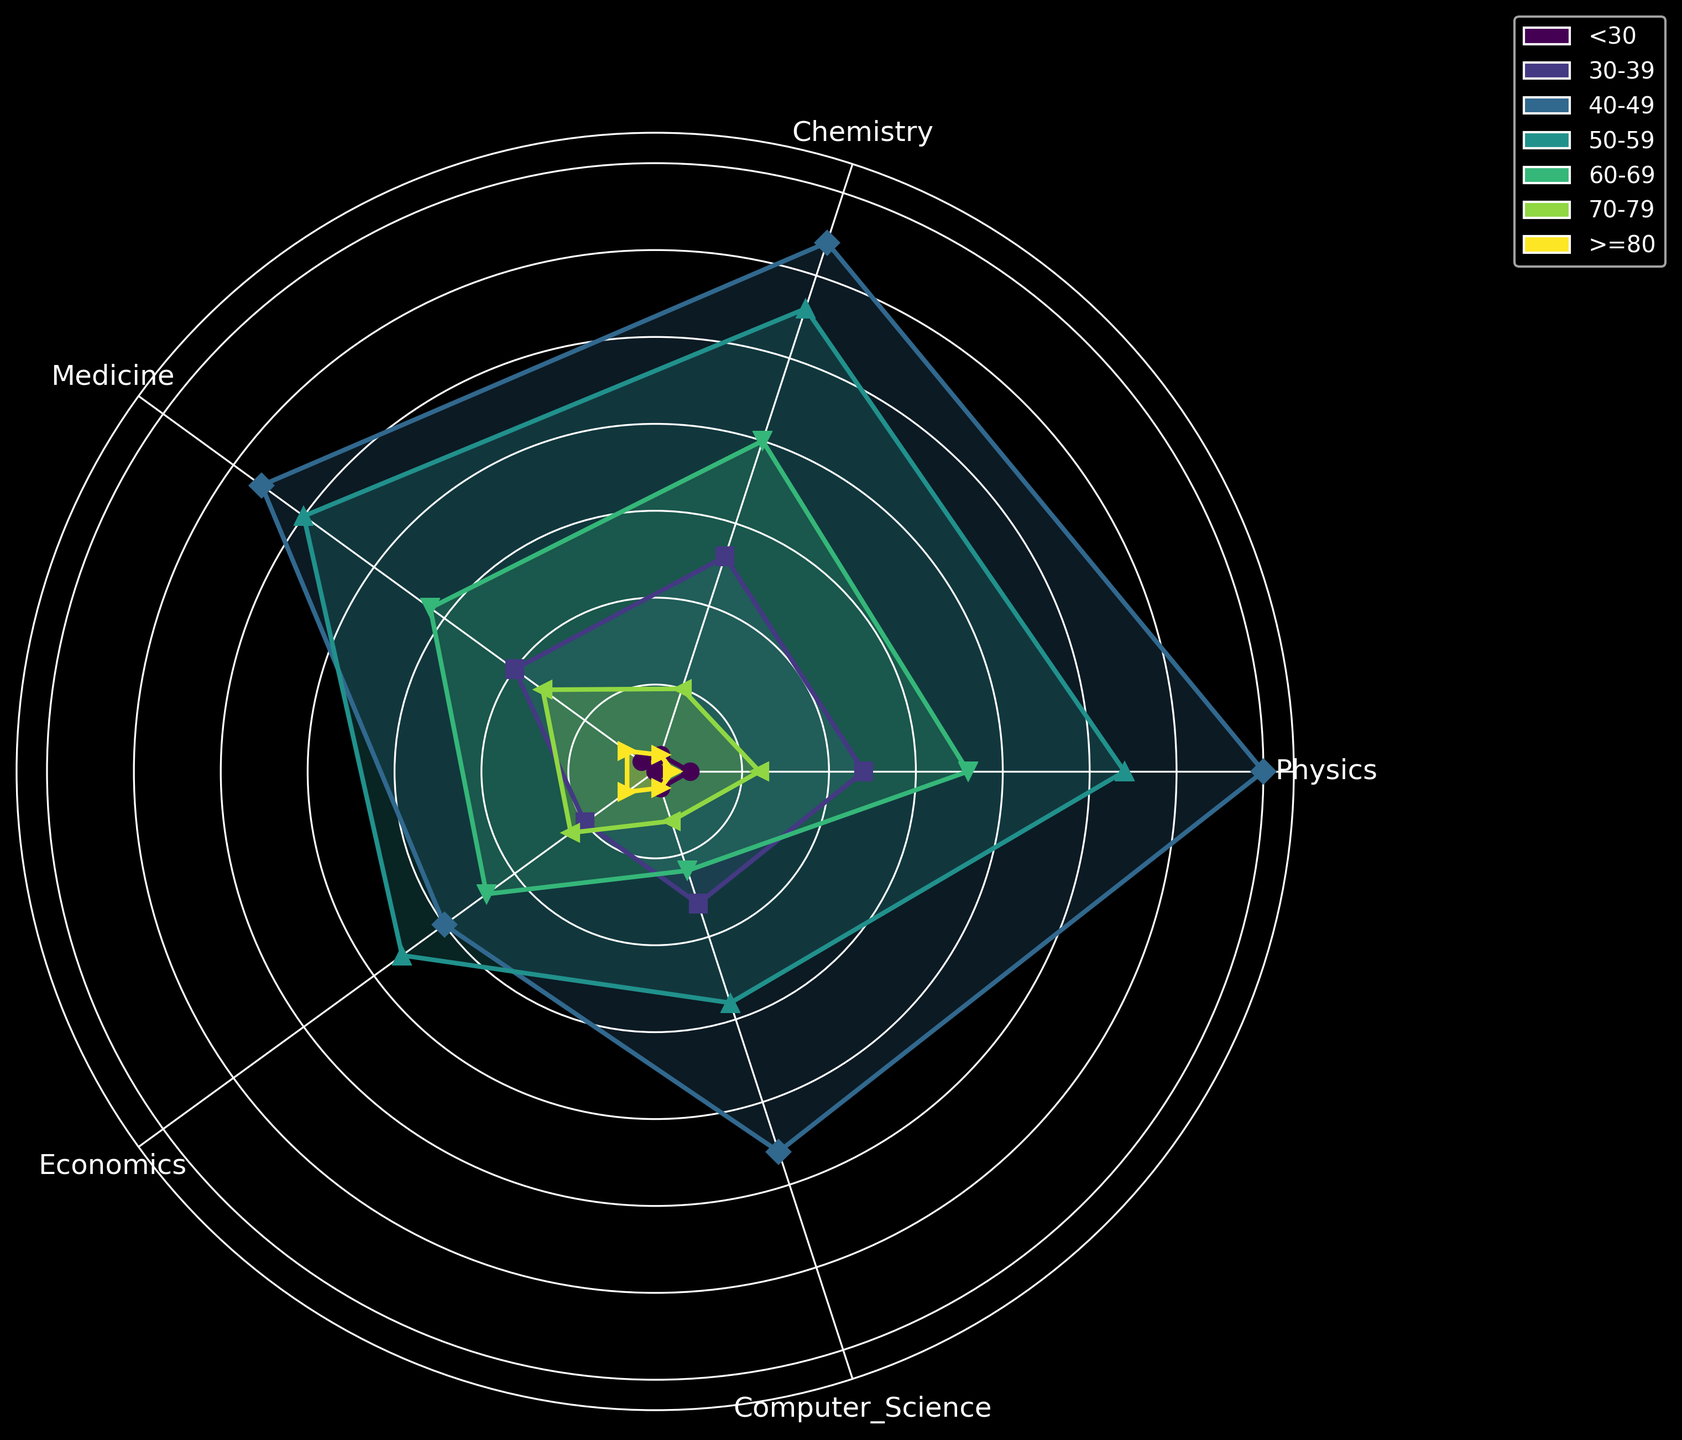What age bracket has the highest number of Nobel laureates in Computer Science? By looking at the filled areas and peak points of each line, the 40-49 age bracket has the highest number of Nobel laureates in Computer Science as indicated by the highest plotted point for this field.
Answer: 40-49 Which age bracket has more Nobel laureates in Medicine: 50-59 or 60-69? To determine this, compare the height of the areas for Medicine under the age brackets 50-59 and 60-69. The 50-59 age bracket has a visibly higher plot point and filled area.
Answer: 50-59 What is the overall trend for Nobel laureates' ages in the field of Physics? Observing the radial plots for Physics, it generally shows that most laureates are in the 40-49 range, with a decline in numbers as the age increases beyond this range.
Answer: Most are 40-49; decline after Which two categories have the closest number of Nobel laureates in the 60-69 age bracket? By examining the 60-69 line segments for all fields, the fields of Physics and Chemistry have plots that are very close in height, indicating similar numbers of laureates.
Answer: Physics and Chemistry Which field has the youngest Nobel laureates on average, based on the distribution shown? To determine this, compare the presence and height of segments below 30 and 30-39 across all fields. Computer Science has a noticeable plot point below 30 and substantial in the 30-39 range, indicating younger laureates on average.
Answer: Computer Science How does the number of Nobel laureates in the >=80 age bracket compare between Chemistry and Economics? Comparing the line segments and plot markers above the 80 age bracket, both Chemistry and Economics have the same plot height and filled area for this age bracket.
Answer: Equal What is the sum of Nobel laureates aged below 30 in Medicine and Physics? By identifying and summing the plot points for below 30 in Medicine (1) and Physics (2), the total is 1+2=3.
Answer: 3 Among the 70-79 age bracket, which field shows the least number of Nobel laureates? Examine the heights of the plots for each field in the 70-79 age bracket. Computer Science has the smallest plot point and filled area, indicating the least number.
Answer: Computer Science 